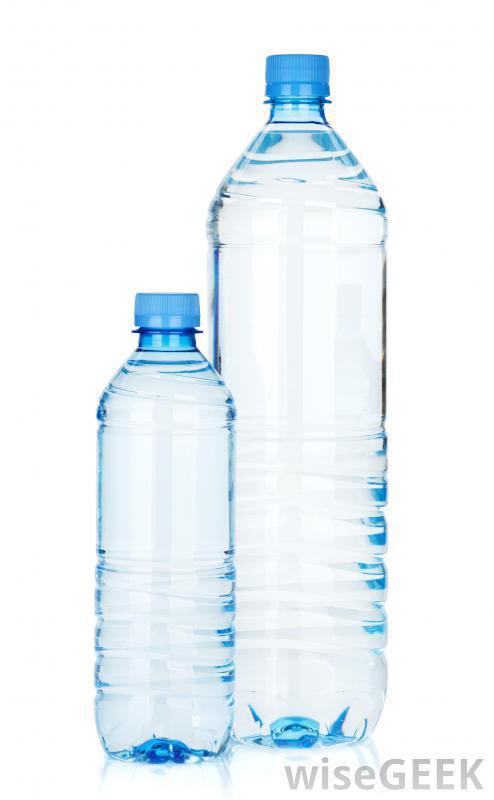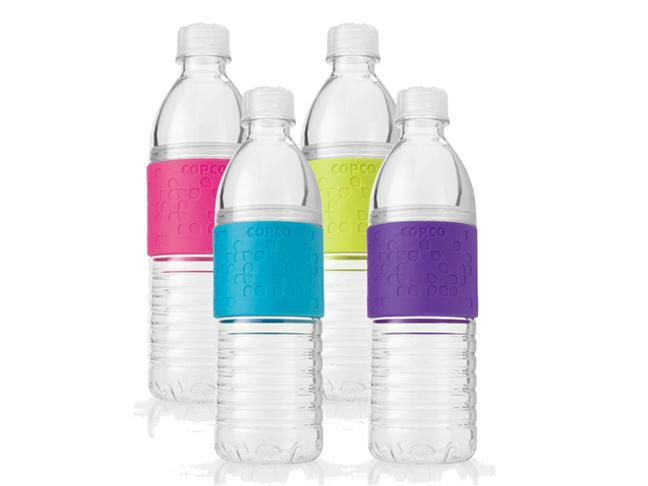The first image is the image on the left, the second image is the image on the right. Examine the images to the left and right. Is the description "An image includes a clear water bottle with exactly three ribbed bands around its upper midsection." accurate? Answer yes or no. No. The first image is the image on the left, the second image is the image on the right. For the images displayed, is the sentence "There are more than three bottles." factually correct? Answer yes or no. Yes. 